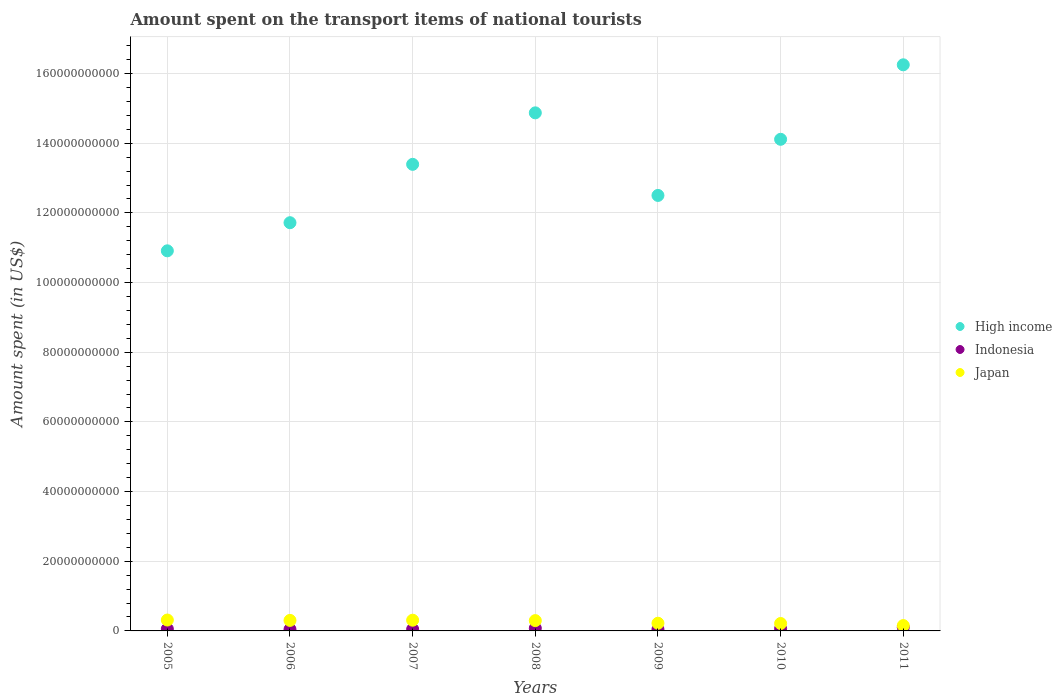How many different coloured dotlines are there?
Keep it short and to the point. 3. What is the amount spent on the transport items of national tourists in High income in 2011?
Make the answer very short. 1.63e+11. Across all years, what is the maximum amount spent on the transport items of national tourists in Indonesia?
Your response must be concise. 1.04e+09. Across all years, what is the minimum amount spent on the transport items of national tourists in High income?
Offer a very short reply. 1.09e+11. In which year was the amount spent on the transport items of national tourists in Japan maximum?
Give a very brief answer. 2005. In which year was the amount spent on the transport items of national tourists in Japan minimum?
Offer a very short reply. 2011. What is the total amount spent on the transport items of national tourists in Japan in the graph?
Offer a very short reply. 1.81e+1. What is the difference between the amount spent on the transport items of national tourists in High income in 2009 and that in 2010?
Make the answer very short. -1.61e+1. What is the difference between the amount spent on the transport items of national tourists in Indonesia in 2011 and the amount spent on the transport items of national tourists in Japan in 2007?
Provide a succinct answer. -2.04e+09. What is the average amount spent on the transport items of national tourists in Japan per year?
Your answer should be very brief. 2.58e+09. In the year 2007, what is the difference between the amount spent on the transport items of national tourists in High income and amount spent on the transport items of national tourists in Japan?
Your answer should be very brief. 1.31e+11. What is the ratio of the amount spent on the transport items of national tourists in Japan in 2006 to that in 2011?
Your answer should be very brief. 1.97. Is the amount spent on the transport items of national tourists in Indonesia in 2005 less than that in 2010?
Provide a succinct answer. Yes. Is the difference between the amount spent on the transport items of national tourists in High income in 2005 and 2009 greater than the difference between the amount spent on the transport items of national tourists in Japan in 2005 and 2009?
Keep it short and to the point. No. What is the difference between the highest and the second highest amount spent on the transport items of national tourists in Japan?
Your answer should be compact. 4.80e+07. What is the difference between the highest and the lowest amount spent on the transport items of national tourists in Japan?
Provide a short and direct response. 1.59e+09. Is the sum of the amount spent on the transport items of national tourists in High income in 2010 and 2011 greater than the maximum amount spent on the transport items of national tourists in Japan across all years?
Keep it short and to the point. Yes. Is it the case that in every year, the sum of the amount spent on the transport items of national tourists in Japan and amount spent on the transport items of national tourists in Indonesia  is greater than the amount spent on the transport items of national tourists in High income?
Offer a very short reply. No. Is the amount spent on the transport items of national tourists in High income strictly greater than the amount spent on the transport items of national tourists in Japan over the years?
Offer a very short reply. Yes. Is the amount spent on the transport items of national tourists in Indonesia strictly less than the amount spent on the transport items of national tourists in High income over the years?
Offer a very short reply. Yes. How many years are there in the graph?
Your answer should be very brief. 7. What is the difference between two consecutive major ticks on the Y-axis?
Your answer should be very brief. 2.00e+1. Does the graph contain any zero values?
Make the answer very short. No. How many legend labels are there?
Provide a short and direct response. 3. How are the legend labels stacked?
Offer a terse response. Vertical. What is the title of the graph?
Your answer should be very brief. Amount spent on the transport items of national tourists. What is the label or title of the Y-axis?
Make the answer very short. Amount spent (in US$). What is the Amount spent (in US$) in High income in 2005?
Ensure brevity in your answer.  1.09e+11. What is the Amount spent (in US$) in Indonesia in 2005?
Your answer should be very brief. 5.72e+08. What is the Amount spent (in US$) in Japan in 2005?
Make the answer very short. 3.12e+09. What is the Amount spent (in US$) in High income in 2006?
Offer a very short reply. 1.17e+11. What is the Amount spent (in US$) of Indonesia in 2006?
Your response must be concise. 4.42e+08. What is the Amount spent (in US$) of Japan in 2006?
Offer a terse response. 3.02e+09. What is the Amount spent (in US$) of High income in 2007?
Your answer should be compact. 1.34e+11. What is the Amount spent (in US$) of Indonesia in 2007?
Provide a short and direct response. 4.85e+08. What is the Amount spent (in US$) in Japan in 2007?
Keep it short and to the point. 3.08e+09. What is the Amount spent (in US$) of High income in 2008?
Offer a very short reply. 1.49e+11. What is the Amount spent (in US$) of Indonesia in 2008?
Provide a succinct answer. 7.73e+08. What is the Amount spent (in US$) in Japan in 2008?
Ensure brevity in your answer.  2.96e+09. What is the Amount spent (in US$) in High income in 2009?
Provide a succinct answer. 1.25e+11. What is the Amount spent (in US$) in Indonesia in 2009?
Offer a very short reply. 4.55e+08. What is the Amount spent (in US$) in Japan in 2009?
Your response must be concise. 2.21e+09. What is the Amount spent (in US$) in High income in 2010?
Your answer should be very brief. 1.41e+11. What is the Amount spent (in US$) in Indonesia in 2010?
Make the answer very short. 6.60e+08. What is the Amount spent (in US$) of Japan in 2010?
Offer a terse response. 2.13e+09. What is the Amount spent (in US$) in High income in 2011?
Your answer should be compact. 1.63e+11. What is the Amount spent (in US$) of Indonesia in 2011?
Provide a short and direct response. 1.04e+09. What is the Amount spent (in US$) of Japan in 2011?
Ensure brevity in your answer.  1.53e+09. Across all years, what is the maximum Amount spent (in US$) of High income?
Your answer should be compact. 1.63e+11. Across all years, what is the maximum Amount spent (in US$) in Indonesia?
Your answer should be compact. 1.04e+09. Across all years, what is the maximum Amount spent (in US$) in Japan?
Offer a very short reply. 3.12e+09. Across all years, what is the minimum Amount spent (in US$) of High income?
Your answer should be very brief. 1.09e+11. Across all years, what is the minimum Amount spent (in US$) of Indonesia?
Keep it short and to the point. 4.42e+08. Across all years, what is the minimum Amount spent (in US$) in Japan?
Ensure brevity in your answer.  1.53e+09. What is the total Amount spent (in US$) in High income in the graph?
Provide a succinct answer. 9.38e+11. What is the total Amount spent (in US$) in Indonesia in the graph?
Offer a very short reply. 4.43e+09. What is the total Amount spent (in US$) of Japan in the graph?
Offer a very short reply. 1.81e+1. What is the difference between the Amount spent (in US$) in High income in 2005 and that in 2006?
Give a very brief answer. -8.07e+09. What is the difference between the Amount spent (in US$) of Indonesia in 2005 and that in 2006?
Your answer should be compact. 1.30e+08. What is the difference between the Amount spent (in US$) of Japan in 2005 and that in 2006?
Provide a succinct answer. 1.05e+08. What is the difference between the Amount spent (in US$) in High income in 2005 and that in 2007?
Provide a succinct answer. -2.48e+1. What is the difference between the Amount spent (in US$) in Indonesia in 2005 and that in 2007?
Make the answer very short. 8.70e+07. What is the difference between the Amount spent (in US$) in Japan in 2005 and that in 2007?
Offer a very short reply. 4.80e+07. What is the difference between the Amount spent (in US$) in High income in 2005 and that in 2008?
Make the answer very short. -3.96e+1. What is the difference between the Amount spent (in US$) of Indonesia in 2005 and that in 2008?
Your answer should be very brief. -2.01e+08. What is the difference between the Amount spent (in US$) in Japan in 2005 and that in 2008?
Give a very brief answer. 1.64e+08. What is the difference between the Amount spent (in US$) in High income in 2005 and that in 2009?
Ensure brevity in your answer.  -1.59e+1. What is the difference between the Amount spent (in US$) of Indonesia in 2005 and that in 2009?
Ensure brevity in your answer.  1.17e+08. What is the difference between the Amount spent (in US$) of Japan in 2005 and that in 2009?
Keep it short and to the point. 9.17e+08. What is the difference between the Amount spent (in US$) of High income in 2005 and that in 2010?
Provide a succinct answer. -3.20e+1. What is the difference between the Amount spent (in US$) in Indonesia in 2005 and that in 2010?
Offer a very short reply. -8.80e+07. What is the difference between the Amount spent (in US$) of Japan in 2005 and that in 2010?
Your response must be concise. 9.93e+08. What is the difference between the Amount spent (in US$) in High income in 2005 and that in 2011?
Your response must be concise. -5.34e+1. What is the difference between the Amount spent (in US$) in Indonesia in 2005 and that in 2011?
Give a very brief answer. -4.69e+08. What is the difference between the Amount spent (in US$) of Japan in 2005 and that in 2011?
Your answer should be compact. 1.59e+09. What is the difference between the Amount spent (in US$) in High income in 2006 and that in 2007?
Your answer should be very brief. -1.68e+1. What is the difference between the Amount spent (in US$) of Indonesia in 2006 and that in 2007?
Provide a short and direct response. -4.30e+07. What is the difference between the Amount spent (in US$) of Japan in 2006 and that in 2007?
Provide a succinct answer. -5.70e+07. What is the difference between the Amount spent (in US$) in High income in 2006 and that in 2008?
Ensure brevity in your answer.  -3.15e+1. What is the difference between the Amount spent (in US$) of Indonesia in 2006 and that in 2008?
Provide a succinct answer. -3.31e+08. What is the difference between the Amount spent (in US$) of Japan in 2006 and that in 2008?
Your answer should be compact. 5.90e+07. What is the difference between the Amount spent (in US$) in High income in 2006 and that in 2009?
Your answer should be very brief. -7.83e+09. What is the difference between the Amount spent (in US$) in Indonesia in 2006 and that in 2009?
Offer a very short reply. -1.30e+07. What is the difference between the Amount spent (in US$) of Japan in 2006 and that in 2009?
Provide a succinct answer. 8.12e+08. What is the difference between the Amount spent (in US$) of High income in 2006 and that in 2010?
Give a very brief answer. -2.39e+1. What is the difference between the Amount spent (in US$) of Indonesia in 2006 and that in 2010?
Offer a terse response. -2.18e+08. What is the difference between the Amount spent (in US$) of Japan in 2006 and that in 2010?
Ensure brevity in your answer.  8.88e+08. What is the difference between the Amount spent (in US$) of High income in 2006 and that in 2011?
Provide a succinct answer. -4.53e+1. What is the difference between the Amount spent (in US$) in Indonesia in 2006 and that in 2011?
Your answer should be compact. -5.99e+08. What is the difference between the Amount spent (in US$) in Japan in 2006 and that in 2011?
Offer a very short reply. 1.49e+09. What is the difference between the Amount spent (in US$) of High income in 2007 and that in 2008?
Provide a short and direct response. -1.48e+1. What is the difference between the Amount spent (in US$) of Indonesia in 2007 and that in 2008?
Your response must be concise. -2.88e+08. What is the difference between the Amount spent (in US$) in Japan in 2007 and that in 2008?
Provide a succinct answer. 1.16e+08. What is the difference between the Amount spent (in US$) in High income in 2007 and that in 2009?
Provide a short and direct response. 8.93e+09. What is the difference between the Amount spent (in US$) of Indonesia in 2007 and that in 2009?
Ensure brevity in your answer.  3.00e+07. What is the difference between the Amount spent (in US$) in Japan in 2007 and that in 2009?
Give a very brief answer. 8.69e+08. What is the difference between the Amount spent (in US$) of High income in 2007 and that in 2010?
Offer a very short reply. -7.19e+09. What is the difference between the Amount spent (in US$) in Indonesia in 2007 and that in 2010?
Your answer should be very brief. -1.75e+08. What is the difference between the Amount spent (in US$) in Japan in 2007 and that in 2010?
Your answer should be very brief. 9.45e+08. What is the difference between the Amount spent (in US$) in High income in 2007 and that in 2011?
Offer a terse response. -2.86e+1. What is the difference between the Amount spent (in US$) in Indonesia in 2007 and that in 2011?
Keep it short and to the point. -5.56e+08. What is the difference between the Amount spent (in US$) in Japan in 2007 and that in 2011?
Give a very brief answer. 1.54e+09. What is the difference between the Amount spent (in US$) of High income in 2008 and that in 2009?
Keep it short and to the point. 2.37e+1. What is the difference between the Amount spent (in US$) in Indonesia in 2008 and that in 2009?
Provide a short and direct response. 3.18e+08. What is the difference between the Amount spent (in US$) of Japan in 2008 and that in 2009?
Make the answer very short. 7.53e+08. What is the difference between the Amount spent (in US$) of High income in 2008 and that in 2010?
Make the answer very short. 7.59e+09. What is the difference between the Amount spent (in US$) in Indonesia in 2008 and that in 2010?
Provide a succinct answer. 1.13e+08. What is the difference between the Amount spent (in US$) in Japan in 2008 and that in 2010?
Your response must be concise. 8.29e+08. What is the difference between the Amount spent (in US$) in High income in 2008 and that in 2011?
Provide a succinct answer. -1.38e+1. What is the difference between the Amount spent (in US$) of Indonesia in 2008 and that in 2011?
Offer a terse response. -2.68e+08. What is the difference between the Amount spent (in US$) in Japan in 2008 and that in 2011?
Keep it short and to the point. 1.43e+09. What is the difference between the Amount spent (in US$) in High income in 2009 and that in 2010?
Provide a short and direct response. -1.61e+1. What is the difference between the Amount spent (in US$) in Indonesia in 2009 and that in 2010?
Offer a very short reply. -2.05e+08. What is the difference between the Amount spent (in US$) of Japan in 2009 and that in 2010?
Offer a very short reply. 7.60e+07. What is the difference between the Amount spent (in US$) in High income in 2009 and that in 2011?
Make the answer very short. -3.75e+1. What is the difference between the Amount spent (in US$) in Indonesia in 2009 and that in 2011?
Your response must be concise. -5.86e+08. What is the difference between the Amount spent (in US$) of Japan in 2009 and that in 2011?
Provide a short and direct response. 6.74e+08. What is the difference between the Amount spent (in US$) of High income in 2010 and that in 2011?
Your response must be concise. -2.14e+1. What is the difference between the Amount spent (in US$) of Indonesia in 2010 and that in 2011?
Your answer should be compact. -3.81e+08. What is the difference between the Amount spent (in US$) in Japan in 2010 and that in 2011?
Offer a terse response. 5.98e+08. What is the difference between the Amount spent (in US$) of High income in 2005 and the Amount spent (in US$) of Indonesia in 2006?
Provide a succinct answer. 1.09e+11. What is the difference between the Amount spent (in US$) in High income in 2005 and the Amount spent (in US$) in Japan in 2006?
Your response must be concise. 1.06e+11. What is the difference between the Amount spent (in US$) in Indonesia in 2005 and the Amount spent (in US$) in Japan in 2006?
Make the answer very short. -2.45e+09. What is the difference between the Amount spent (in US$) of High income in 2005 and the Amount spent (in US$) of Indonesia in 2007?
Make the answer very short. 1.09e+11. What is the difference between the Amount spent (in US$) in High income in 2005 and the Amount spent (in US$) in Japan in 2007?
Give a very brief answer. 1.06e+11. What is the difference between the Amount spent (in US$) of Indonesia in 2005 and the Amount spent (in US$) of Japan in 2007?
Your answer should be very brief. -2.50e+09. What is the difference between the Amount spent (in US$) of High income in 2005 and the Amount spent (in US$) of Indonesia in 2008?
Keep it short and to the point. 1.08e+11. What is the difference between the Amount spent (in US$) in High income in 2005 and the Amount spent (in US$) in Japan in 2008?
Provide a short and direct response. 1.06e+11. What is the difference between the Amount spent (in US$) in Indonesia in 2005 and the Amount spent (in US$) in Japan in 2008?
Provide a succinct answer. -2.39e+09. What is the difference between the Amount spent (in US$) in High income in 2005 and the Amount spent (in US$) in Indonesia in 2009?
Offer a very short reply. 1.09e+11. What is the difference between the Amount spent (in US$) of High income in 2005 and the Amount spent (in US$) of Japan in 2009?
Give a very brief answer. 1.07e+11. What is the difference between the Amount spent (in US$) in Indonesia in 2005 and the Amount spent (in US$) in Japan in 2009?
Ensure brevity in your answer.  -1.64e+09. What is the difference between the Amount spent (in US$) of High income in 2005 and the Amount spent (in US$) of Indonesia in 2010?
Provide a short and direct response. 1.08e+11. What is the difference between the Amount spent (in US$) of High income in 2005 and the Amount spent (in US$) of Japan in 2010?
Provide a short and direct response. 1.07e+11. What is the difference between the Amount spent (in US$) of Indonesia in 2005 and the Amount spent (in US$) of Japan in 2010?
Your response must be concise. -1.56e+09. What is the difference between the Amount spent (in US$) of High income in 2005 and the Amount spent (in US$) of Indonesia in 2011?
Make the answer very short. 1.08e+11. What is the difference between the Amount spent (in US$) in High income in 2005 and the Amount spent (in US$) in Japan in 2011?
Make the answer very short. 1.08e+11. What is the difference between the Amount spent (in US$) of Indonesia in 2005 and the Amount spent (in US$) of Japan in 2011?
Provide a succinct answer. -9.62e+08. What is the difference between the Amount spent (in US$) in High income in 2006 and the Amount spent (in US$) in Indonesia in 2007?
Offer a very short reply. 1.17e+11. What is the difference between the Amount spent (in US$) of High income in 2006 and the Amount spent (in US$) of Japan in 2007?
Keep it short and to the point. 1.14e+11. What is the difference between the Amount spent (in US$) in Indonesia in 2006 and the Amount spent (in US$) in Japan in 2007?
Your response must be concise. -2.64e+09. What is the difference between the Amount spent (in US$) of High income in 2006 and the Amount spent (in US$) of Indonesia in 2008?
Give a very brief answer. 1.16e+11. What is the difference between the Amount spent (in US$) of High income in 2006 and the Amount spent (in US$) of Japan in 2008?
Provide a short and direct response. 1.14e+11. What is the difference between the Amount spent (in US$) of Indonesia in 2006 and the Amount spent (in US$) of Japan in 2008?
Ensure brevity in your answer.  -2.52e+09. What is the difference between the Amount spent (in US$) in High income in 2006 and the Amount spent (in US$) in Indonesia in 2009?
Give a very brief answer. 1.17e+11. What is the difference between the Amount spent (in US$) in High income in 2006 and the Amount spent (in US$) in Japan in 2009?
Provide a short and direct response. 1.15e+11. What is the difference between the Amount spent (in US$) of Indonesia in 2006 and the Amount spent (in US$) of Japan in 2009?
Offer a terse response. -1.77e+09. What is the difference between the Amount spent (in US$) of High income in 2006 and the Amount spent (in US$) of Indonesia in 2010?
Provide a succinct answer. 1.17e+11. What is the difference between the Amount spent (in US$) in High income in 2006 and the Amount spent (in US$) in Japan in 2010?
Provide a short and direct response. 1.15e+11. What is the difference between the Amount spent (in US$) of Indonesia in 2006 and the Amount spent (in US$) of Japan in 2010?
Offer a terse response. -1.69e+09. What is the difference between the Amount spent (in US$) of High income in 2006 and the Amount spent (in US$) of Indonesia in 2011?
Provide a short and direct response. 1.16e+11. What is the difference between the Amount spent (in US$) in High income in 2006 and the Amount spent (in US$) in Japan in 2011?
Your response must be concise. 1.16e+11. What is the difference between the Amount spent (in US$) in Indonesia in 2006 and the Amount spent (in US$) in Japan in 2011?
Offer a terse response. -1.09e+09. What is the difference between the Amount spent (in US$) of High income in 2007 and the Amount spent (in US$) of Indonesia in 2008?
Ensure brevity in your answer.  1.33e+11. What is the difference between the Amount spent (in US$) in High income in 2007 and the Amount spent (in US$) in Japan in 2008?
Your answer should be very brief. 1.31e+11. What is the difference between the Amount spent (in US$) of Indonesia in 2007 and the Amount spent (in US$) of Japan in 2008?
Give a very brief answer. -2.48e+09. What is the difference between the Amount spent (in US$) of High income in 2007 and the Amount spent (in US$) of Indonesia in 2009?
Keep it short and to the point. 1.33e+11. What is the difference between the Amount spent (in US$) in High income in 2007 and the Amount spent (in US$) in Japan in 2009?
Make the answer very short. 1.32e+11. What is the difference between the Amount spent (in US$) of Indonesia in 2007 and the Amount spent (in US$) of Japan in 2009?
Make the answer very short. -1.72e+09. What is the difference between the Amount spent (in US$) in High income in 2007 and the Amount spent (in US$) in Indonesia in 2010?
Provide a short and direct response. 1.33e+11. What is the difference between the Amount spent (in US$) of High income in 2007 and the Amount spent (in US$) of Japan in 2010?
Provide a short and direct response. 1.32e+11. What is the difference between the Amount spent (in US$) in Indonesia in 2007 and the Amount spent (in US$) in Japan in 2010?
Your answer should be compact. -1.65e+09. What is the difference between the Amount spent (in US$) of High income in 2007 and the Amount spent (in US$) of Indonesia in 2011?
Offer a very short reply. 1.33e+11. What is the difference between the Amount spent (in US$) in High income in 2007 and the Amount spent (in US$) in Japan in 2011?
Make the answer very short. 1.32e+11. What is the difference between the Amount spent (in US$) of Indonesia in 2007 and the Amount spent (in US$) of Japan in 2011?
Provide a short and direct response. -1.05e+09. What is the difference between the Amount spent (in US$) in High income in 2008 and the Amount spent (in US$) in Indonesia in 2009?
Offer a terse response. 1.48e+11. What is the difference between the Amount spent (in US$) of High income in 2008 and the Amount spent (in US$) of Japan in 2009?
Offer a terse response. 1.47e+11. What is the difference between the Amount spent (in US$) in Indonesia in 2008 and the Amount spent (in US$) in Japan in 2009?
Offer a very short reply. -1.44e+09. What is the difference between the Amount spent (in US$) in High income in 2008 and the Amount spent (in US$) in Indonesia in 2010?
Ensure brevity in your answer.  1.48e+11. What is the difference between the Amount spent (in US$) in High income in 2008 and the Amount spent (in US$) in Japan in 2010?
Your answer should be very brief. 1.47e+11. What is the difference between the Amount spent (in US$) of Indonesia in 2008 and the Amount spent (in US$) of Japan in 2010?
Make the answer very short. -1.36e+09. What is the difference between the Amount spent (in US$) in High income in 2008 and the Amount spent (in US$) in Indonesia in 2011?
Your answer should be compact. 1.48e+11. What is the difference between the Amount spent (in US$) in High income in 2008 and the Amount spent (in US$) in Japan in 2011?
Give a very brief answer. 1.47e+11. What is the difference between the Amount spent (in US$) in Indonesia in 2008 and the Amount spent (in US$) in Japan in 2011?
Ensure brevity in your answer.  -7.61e+08. What is the difference between the Amount spent (in US$) of High income in 2009 and the Amount spent (in US$) of Indonesia in 2010?
Offer a terse response. 1.24e+11. What is the difference between the Amount spent (in US$) of High income in 2009 and the Amount spent (in US$) of Japan in 2010?
Your answer should be compact. 1.23e+11. What is the difference between the Amount spent (in US$) in Indonesia in 2009 and the Amount spent (in US$) in Japan in 2010?
Provide a short and direct response. -1.68e+09. What is the difference between the Amount spent (in US$) of High income in 2009 and the Amount spent (in US$) of Indonesia in 2011?
Offer a terse response. 1.24e+11. What is the difference between the Amount spent (in US$) of High income in 2009 and the Amount spent (in US$) of Japan in 2011?
Your answer should be compact. 1.23e+11. What is the difference between the Amount spent (in US$) of Indonesia in 2009 and the Amount spent (in US$) of Japan in 2011?
Your answer should be compact. -1.08e+09. What is the difference between the Amount spent (in US$) of High income in 2010 and the Amount spent (in US$) of Indonesia in 2011?
Your answer should be compact. 1.40e+11. What is the difference between the Amount spent (in US$) in High income in 2010 and the Amount spent (in US$) in Japan in 2011?
Your response must be concise. 1.40e+11. What is the difference between the Amount spent (in US$) of Indonesia in 2010 and the Amount spent (in US$) of Japan in 2011?
Keep it short and to the point. -8.74e+08. What is the average Amount spent (in US$) in High income per year?
Your answer should be compact. 1.34e+11. What is the average Amount spent (in US$) in Indonesia per year?
Provide a short and direct response. 6.33e+08. What is the average Amount spent (in US$) of Japan per year?
Make the answer very short. 2.58e+09. In the year 2005, what is the difference between the Amount spent (in US$) of High income and Amount spent (in US$) of Indonesia?
Give a very brief answer. 1.09e+11. In the year 2005, what is the difference between the Amount spent (in US$) in High income and Amount spent (in US$) in Japan?
Your response must be concise. 1.06e+11. In the year 2005, what is the difference between the Amount spent (in US$) of Indonesia and Amount spent (in US$) of Japan?
Make the answer very short. -2.55e+09. In the year 2006, what is the difference between the Amount spent (in US$) in High income and Amount spent (in US$) in Indonesia?
Offer a terse response. 1.17e+11. In the year 2006, what is the difference between the Amount spent (in US$) of High income and Amount spent (in US$) of Japan?
Offer a terse response. 1.14e+11. In the year 2006, what is the difference between the Amount spent (in US$) of Indonesia and Amount spent (in US$) of Japan?
Offer a terse response. -2.58e+09. In the year 2007, what is the difference between the Amount spent (in US$) in High income and Amount spent (in US$) in Indonesia?
Your answer should be very brief. 1.33e+11. In the year 2007, what is the difference between the Amount spent (in US$) of High income and Amount spent (in US$) of Japan?
Offer a terse response. 1.31e+11. In the year 2007, what is the difference between the Amount spent (in US$) in Indonesia and Amount spent (in US$) in Japan?
Provide a short and direct response. -2.59e+09. In the year 2008, what is the difference between the Amount spent (in US$) of High income and Amount spent (in US$) of Indonesia?
Offer a very short reply. 1.48e+11. In the year 2008, what is the difference between the Amount spent (in US$) in High income and Amount spent (in US$) in Japan?
Give a very brief answer. 1.46e+11. In the year 2008, what is the difference between the Amount spent (in US$) of Indonesia and Amount spent (in US$) of Japan?
Your answer should be compact. -2.19e+09. In the year 2009, what is the difference between the Amount spent (in US$) in High income and Amount spent (in US$) in Indonesia?
Give a very brief answer. 1.25e+11. In the year 2009, what is the difference between the Amount spent (in US$) in High income and Amount spent (in US$) in Japan?
Keep it short and to the point. 1.23e+11. In the year 2009, what is the difference between the Amount spent (in US$) in Indonesia and Amount spent (in US$) in Japan?
Your response must be concise. -1.75e+09. In the year 2010, what is the difference between the Amount spent (in US$) of High income and Amount spent (in US$) of Indonesia?
Ensure brevity in your answer.  1.40e+11. In the year 2010, what is the difference between the Amount spent (in US$) in High income and Amount spent (in US$) in Japan?
Offer a very short reply. 1.39e+11. In the year 2010, what is the difference between the Amount spent (in US$) of Indonesia and Amount spent (in US$) of Japan?
Give a very brief answer. -1.47e+09. In the year 2011, what is the difference between the Amount spent (in US$) in High income and Amount spent (in US$) in Indonesia?
Ensure brevity in your answer.  1.61e+11. In the year 2011, what is the difference between the Amount spent (in US$) in High income and Amount spent (in US$) in Japan?
Provide a short and direct response. 1.61e+11. In the year 2011, what is the difference between the Amount spent (in US$) of Indonesia and Amount spent (in US$) of Japan?
Offer a very short reply. -4.93e+08. What is the ratio of the Amount spent (in US$) of High income in 2005 to that in 2006?
Your answer should be compact. 0.93. What is the ratio of the Amount spent (in US$) of Indonesia in 2005 to that in 2006?
Provide a succinct answer. 1.29. What is the ratio of the Amount spent (in US$) of Japan in 2005 to that in 2006?
Your answer should be compact. 1.03. What is the ratio of the Amount spent (in US$) in High income in 2005 to that in 2007?
Give a very brief answer. 0.81. What is the ratio of the Amount spent (in US$) in Indonesia in 2005 to that in 2007?
Your response must be concise. 1.18. What is the ratio of the Amount spent (in US$) of Japan in 2005 to that in 2007?
Ensure brevity in your answer.  1.02. What is the ratio of the Amount spent (in US$) of High income in 2005 to that in 2008?
Ensure brevity in your answer.  0.73. What is the ratio of the Amount spent (in US$) of Indonesia in 2005 to that in 2008?
Your response must be concise. 0.74. What is the ratio of the Amount spent (in US$) of Japan in 2005 to that in 2008?
Offer a terse response. 1.06. What is the ratio of the Amount spent (in US$) of High income in 2005 to that in 2009?
Your response must be concise. 0.87. What is the ratio of the Amount spent (in US$) of Indonesia in 2005 to that in 2009?
Make the answer very short. 1.26. What is the ratio of the Amount spent (in US$) of Japan in 2005 to that in 2009?
Make the answer very short. 1.42. What is the ratio of the Amount spent (in US$) in High income in 2005 to that in 2010?
Provide a succinct answer. 0.77. What is the ratio of the Amount spent (in US$) of Indonesia in 2005 to that in 2010?
Your answer should be compact. 0.87. What is the ratio of the Amount spent (in US$) of Japan in 2005 to that in 2010?
Make the answer very short. 1.47. What is the ratio of the Amount spent (in US$) in High income in 2005 to that in 2011?
Your response must be concise. 0.67. What is the ratio of the Amount spent (in US$) in Indonesia in 2005 to that in 2011?
Ensure brevity in your answer.  0.55. What is the ratio of the Amount spent (in US$) in Japan in 2005 to that in 2011?
Make the answer very short. 2.04. What is the ratio of the Amount spent (in US$) of High income in 2006 to that in 2007?
Your answer should be compact. 0.87. What is the ratio of the Amount spent (in US$) of Indonesia in 2006 to that in 2007?
Give a very brief answer. 0.91. What is the ratio of the Amount spent (in US$) in Japan in 2006 to that in 2007?
Offer a very short reply. 0.98. What is the ratio of the Amount spent (in US$) in High income in 2006 to that in 2008?
Provide a short and direct response. 0.79. What is the ratio of the Amount spent (in US$) of Indonesia in 2006 to that in 2008?
Keep it short and to the point. 0.57. What is the ratio of the Amount spent (in US$) of Japan in 2006 to that in 2008?
Offer a very short reply. 1.02. What is the ratio of the Amount spent (in US$) in High income in 2006 to that in 2009?
Your answer should be compact. 0.94. What is the ratio of the Amount spent (in US$) of Indonesia in 2006 to that in 2009?
Offer a terse response. 0.97. What is the ratio of the Amount spent (in US$) in Japan in 2006 to that in 2009?
Your answer should be compact. 1.37. What is the ratio of the Amount spent (in US$) of High income in 2006 to that in 2010?
Offer a terse response. 0.83. What is the ratio of the Amount spent (in US$) of Indonesia in 2006 to that in 2010?
Provide a short and direct response. 0.67. What is the ratio of the Amount spent (in US$) in Japan in 2006 to that in 2010?
Make the answer very short. 1.42. What is the ratio of the Amount spent (in US$) in High income in 2006 to that in 2011?
Offer a very short reply. 0.72. What is the ratio of the Amount spent (in US$) of Indonesia in 2006 to that in 2011?
Your response must be concise. 0.42. What is the ratio of the Amount spent (in US$) of Japan in 2006 to that in 2011?
Your answer should be compact. 1.97. What is the ratio of the Amount spent (in US$) in High income in 2007 to that in 2008?
Offer a terse response. 0.9. What is the ratio of the Amount spent (in US$) in Indonesia in 2007 to that in 2008?
Your response must be concise. 0.63. What is the ratio of the Amount spent (in US$) in Japan in 2007 to that in 2008?
Your answer should be compact. 1.04. What is the ratio of the Amount spent (in US$) of High income in 2007 to that in 2009?
Provide a succinct answer. 1.07. What is the ratio of the Amount spent (in US$) of Indonesia in 2007 to that in 2009?
Ensure brevity in your answer.  1.07. What is the ratio of the Amount spent (in US$) in Japan in 2007 to that in 2009?
Provide a short and direct response. 1.39. What is the ratio of the Amount spent (in US$) of High income in 2007 to that in 2010?
Make the answer very short. 0.95. What is the ratio of the Amount spent (in US$) in Indonesia in 2007 to that in 2010?
Give a very brief answer. 0.73. What is the ratio of the Amount spent (in US$) of Japan in 2007 to that in 2010?
Ensure brevity in your answer.  1.44. What is the ratio of the Amount spent (in US$) of High income in 2007 to that in 2011?
Keep it short and to the point. 0.82. What is the ratio of the Amount spent (in US$) of Indonesia in 2007 to that in 2011?
Make the answer very short. 0.47. What is the ratio of the Amount spent (in US$) of Japan in 2007 to that in 2011?
Offer a very short reply. 2.01. What is the ratio of the Amount spent (in US$) of High income in 2008 to that in 2009?
Provide a short and direct response. 1.19. What is the ratio of the Amount spent (in US$) in Indonesia in 2008 to that in 2009?
Ensure brevity in your answer.  1.7. What is the ratio of the Amount spent (in US$) in Japan in 2008 to that in 2009?
Keep it short and to the point. 1.34. What is the ratio of the Amount spent (in US$) of High income in 2008 to that in 2010?
Your answer should be compact. 1.05. What is the ratio of the Amount spent (in US$) in Indonesia in 2008 to that in 2010?
Your answer should be very brief. 1.17. What is the ratio of the Amount spent (in US$) in Japan in 2008 to that in 2010?
Ensure brevity in your answer.  1.39. What is the ratio of the Amount spent (in US$) of High income in 2008 to that in 2011?
Your answer should be compact. 0.92. What is the ratio of the Amount spent (in US$) in Indonesia in 2008 to that in 2011?
Make the answer very short. 0.74. What is the ratio of the Amount spent (in US$) of Japan in 2008 to that in 2011?
Your response must be concise. 1.93. What is the ratio of the Amount spent (in US$) of High income in 2009 to that in 2010?
Your answer should be very brief. 0.89. What is the ratio of the Amount spent (in US$) of Indonesia in 2009 to that in 2010?
Provide a short and direct response. 0.69. What is the ratio of the Amount spent (in US$) of Japan in 2009 to that in 2010?
Ensure brevity in your answer.  1.04. What is the ratio of the Amount spent (in US$) in High income in 2009 to that in 2011?
Provide a short and direct response. 0.77. What is the ratio of the Amount spent (in US$) of Indonesia in 2009 to that in 2011?
Offer a very short reply. 0.44. What is the ratio of the Amount spent (in US$) of Japan in 2009 to that in 2011?
Your answer should be compact. 1.44. What is the ratio of the Amount spent (in US$) of High income in 2010 to that in 2011?
Your answer should be very brief. 0.87. What is the ratio of the Amount spent (in US$) of Indonesia in 2010 to that in 2011?
Offer a terse response. 0.63. What is the ratio of the Amount spent (in US$) in Japan in 2010 to that in 2011?
Your response must be concise. 1.39. What is the difference between the highest and the second highest Amount spent (in US$) in High income?
Make the answer very short. 1.38e+1. What is the difference between the highest and the second highest Amount spent (in US$) of Indonesia?
Provide a short and direct response. 2.68e+08. What is the difference between the highest and the second highest Amount spent (in US$) of Japan?
Provide a succinct answer. 4.80e+07. What is the difference between the highest and the lowest Amount spent (in US$) in High income?
Provide a short and direct response. 5.34e+1. What is the difference between the highest and the lowest Amount spent (in US$) in Indonesia?
Your response must be concise. 5.99e+08. What is the difference between the highest and the lowest Amount spent (in US$) of Japan?
Offer a terse response. 1.59e+09. 